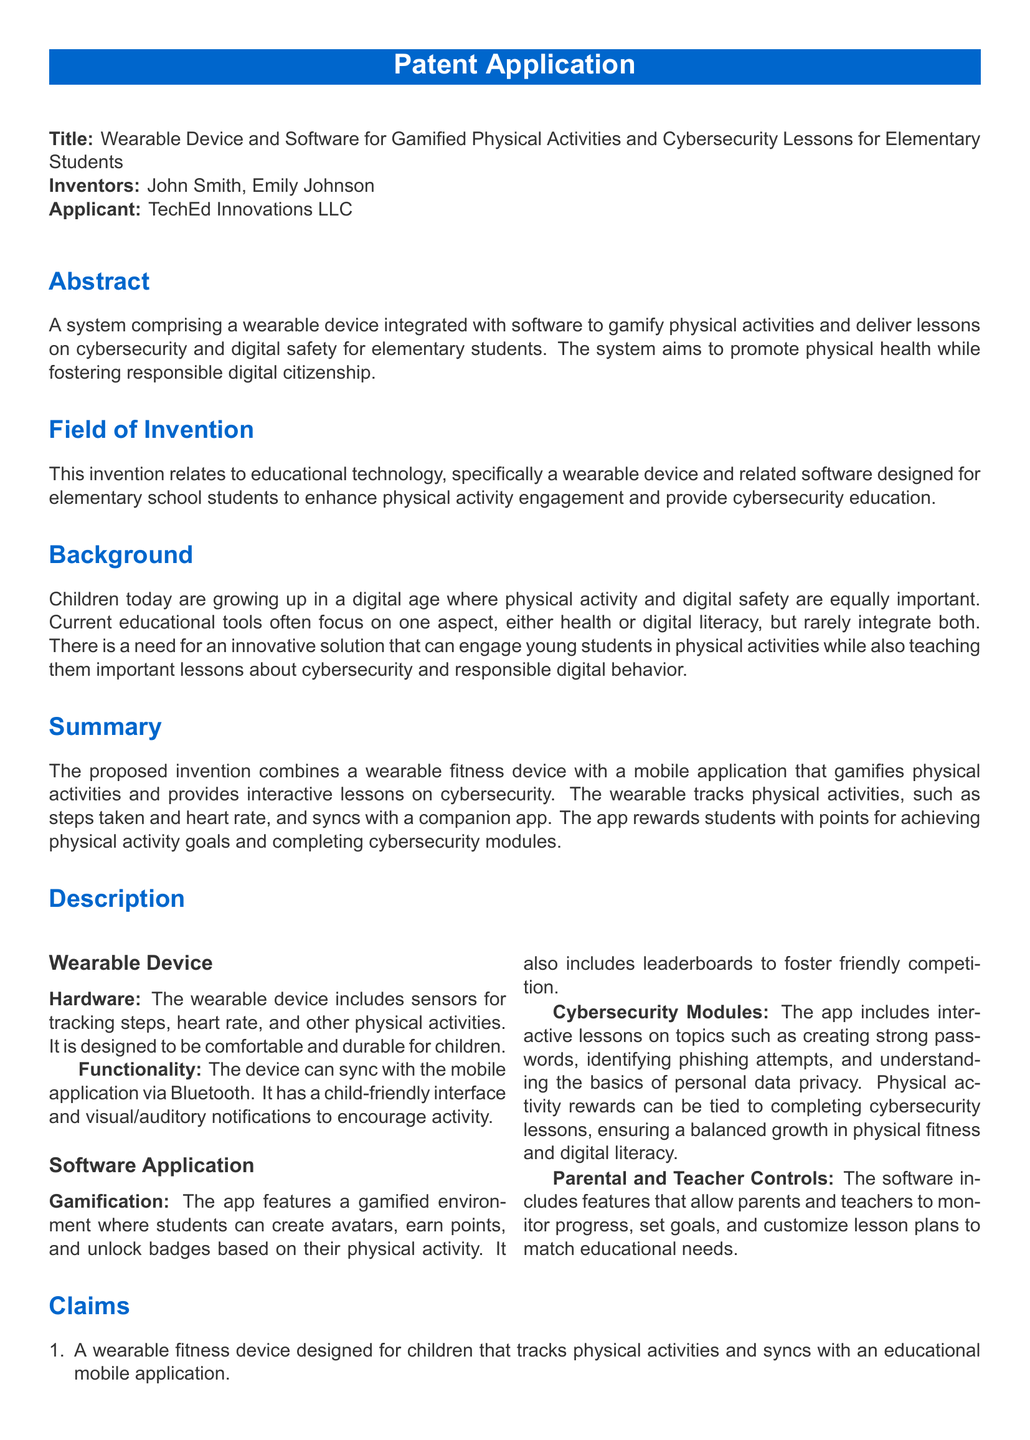What is the title of the patent application? The title is stated directly at the top of the document.
Answer: Wearable Device and Software for Gamified Physical Activities and Cybersecurity Lessons for Elementary Students Who are the inventors of the device? The names of the inventors are listed clearly in the inventor section.
Answer: John Smith, Emily Johnson What is the main goal of the system? The abstract summarizes the primary aim of the invention.
Answer: Promote physical health while fostering responsible digital citizenship What types of lessons does the software provide? The description section mentions the specific topics covered by the app.
Answer: Cybersecurity and digital safety Which features allow parental and teacher involvement? The software description outlines specific functionalities for adults.
Answer: Monitoring progress, setting goals, and customizing lesson plans How does the wearable device track activities? The description lists the types of sensors included in the device.
Answer: Sensors for tracking steps, heart rate, and other physical activities What is the purpose of gamification in the app? The software description explains the function of gamification.
Answer: Encourage physical activity and provide interactive lessons How many claims does the patent include? The claims section provides a numbered list of the claims made in the patent.
Answer: Four 